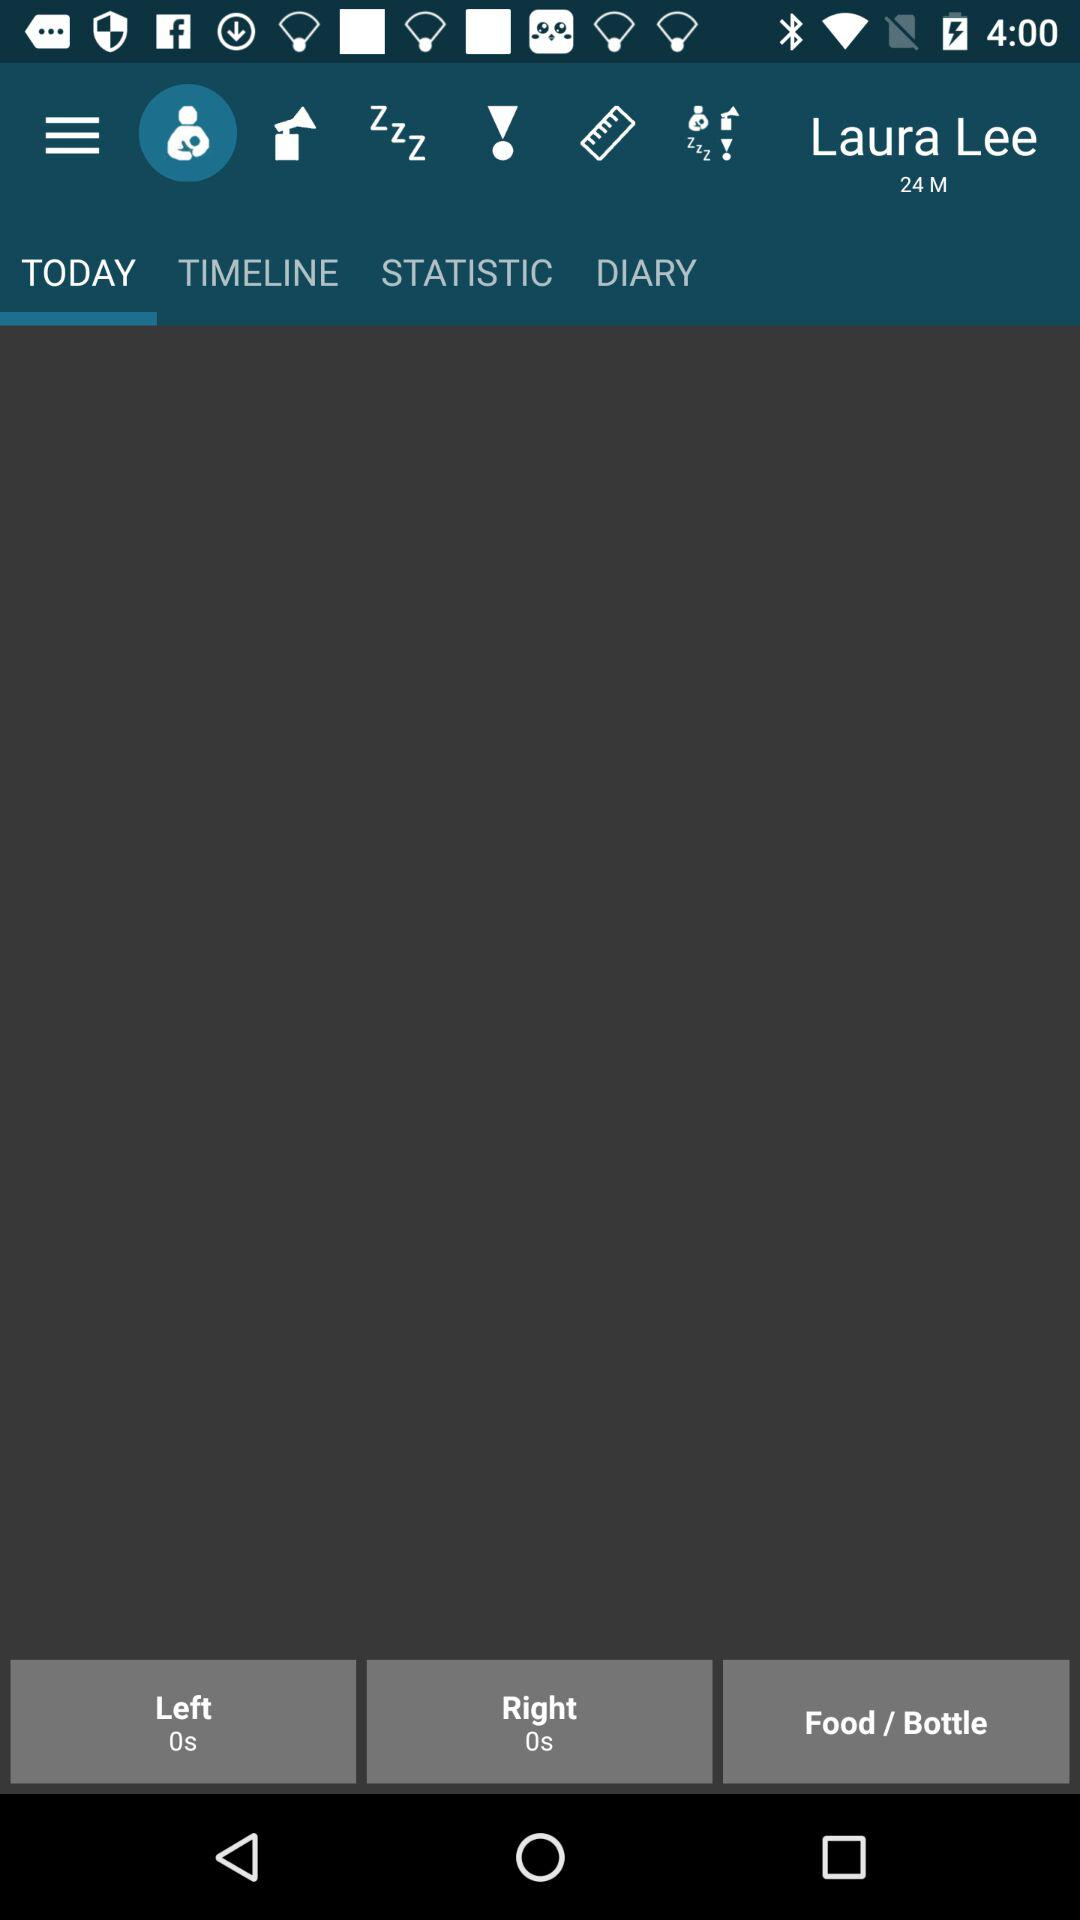What is the name of the user? The name of the user is Laura Lee. 